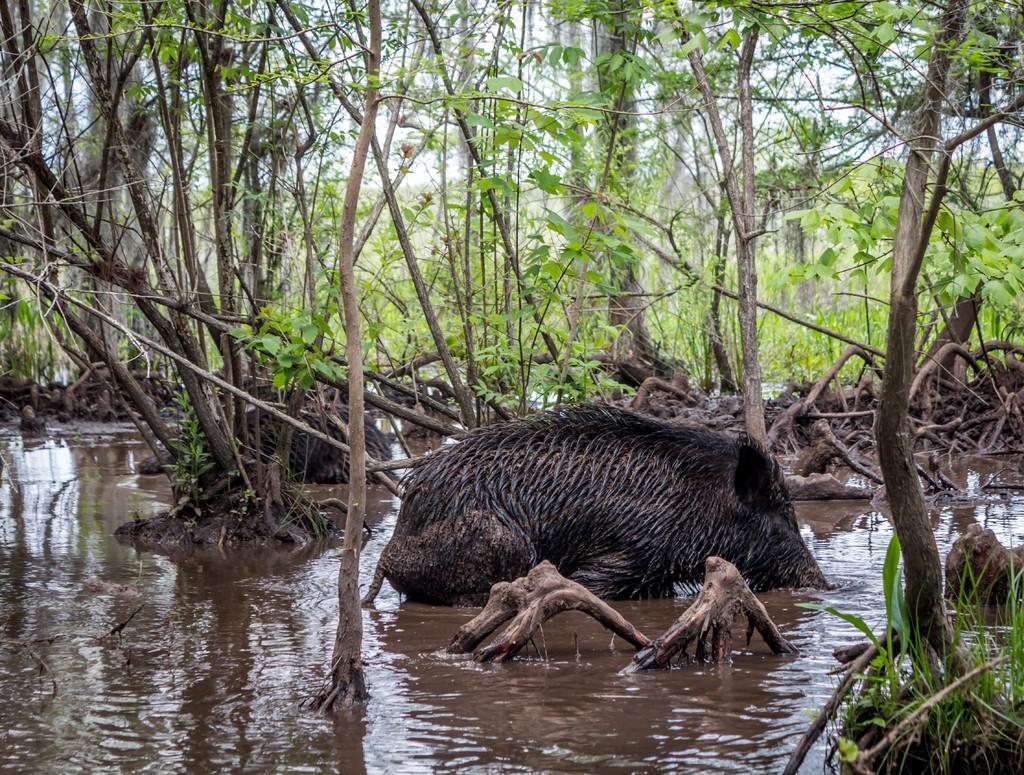How would you summarize this image in a sentence or two? In this image we can see a pig is in the water, behind so many trees are there. 